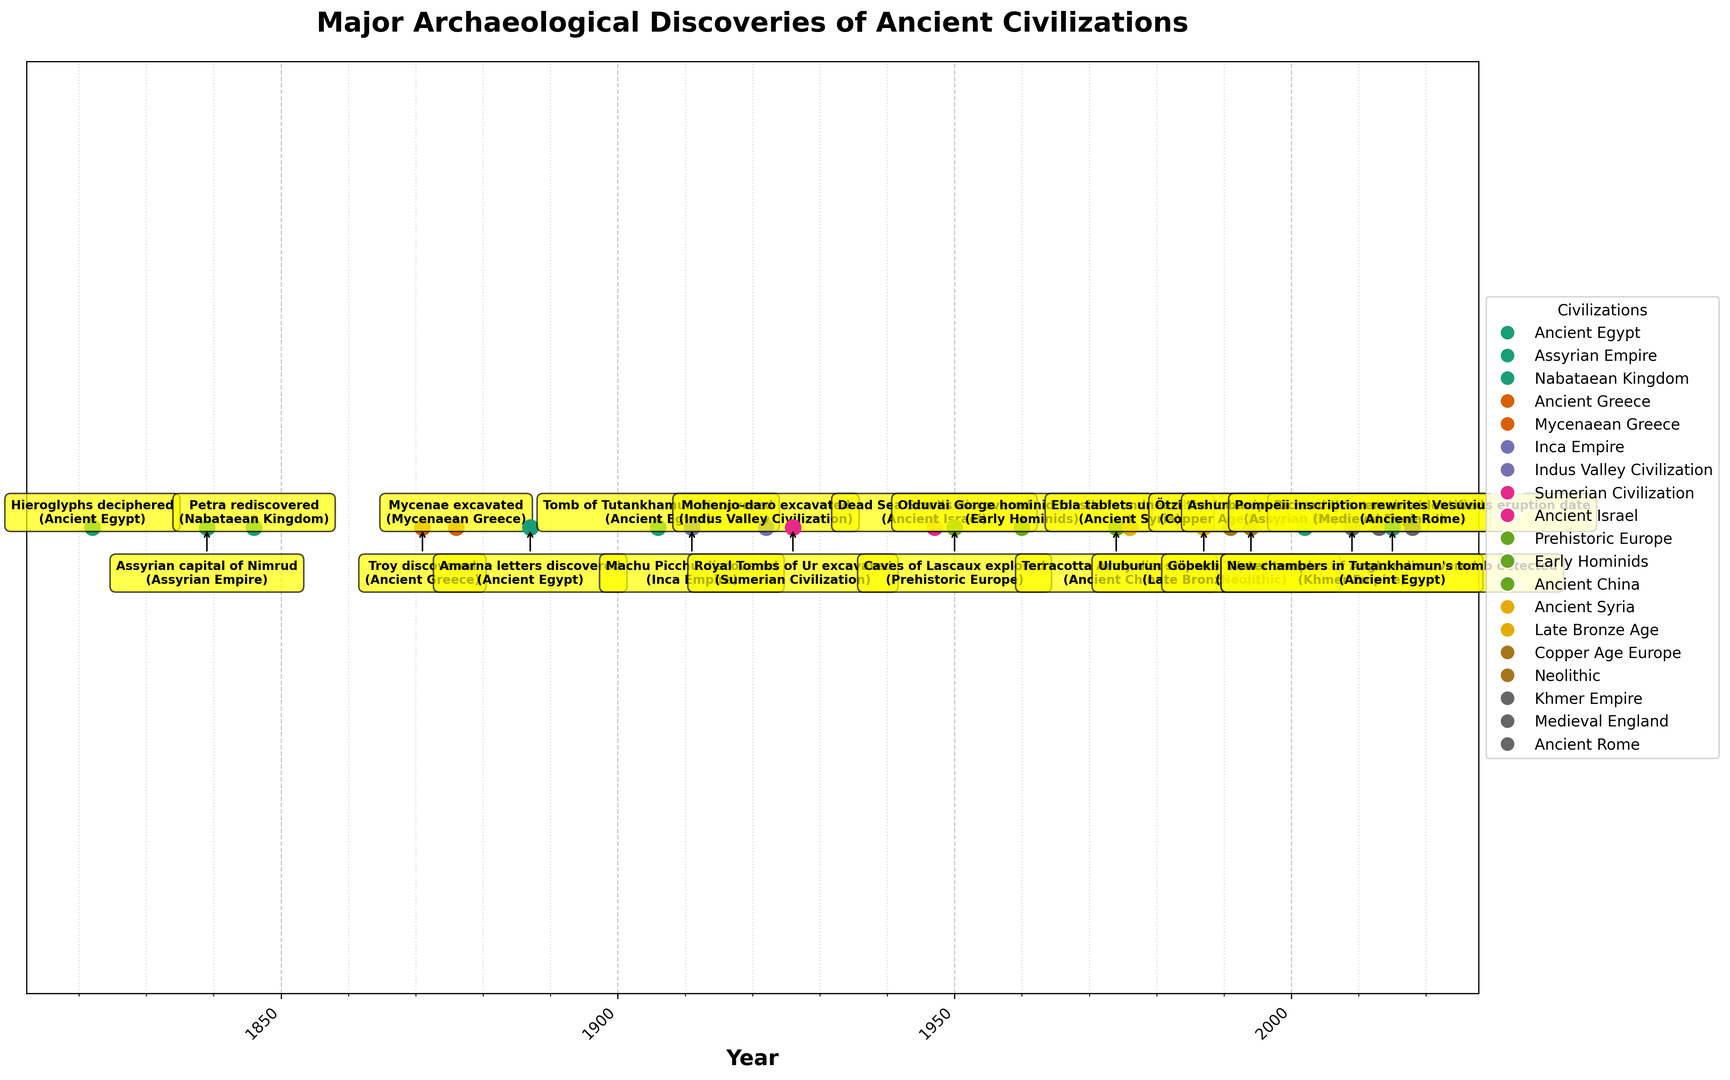What's the most recent archaeological discovery noted on the plot? The plot shows that the most recent discovery is the "Pompeii inscription rewrites Vesuvius eruption date" made in 2018. You can identify the year 2018 as the latest data point along the timeline on the x-axis.
Answer: Pompeii inscription in 2018 Which civilization had the highest number of major discoveries based on the plot? Looking at the plot, you can count the number of discoveries for each civilization. Ancient Egypt has the highest number of major discoveries with four events: Hieroglyphs deciphered (1822), Amarna letters discovered (1887), Tomb of Tutankhamun discovered (1906), and New chambers in Tutankhamun's tomb detected (2015).
Answer: Ancient Egypt What are the years of the discoveries related to the Assyrian Empire on the plot? By observing the labels and colors, we can identify the Assyrian Empire discoveries: "Assyrian capital of Nimrud" in 1839 and "Ashurbanipal's Library catalogued" in 2002.
Answer: 1839 and 2002 Which discovery related to the Neolithic era is noted on the plot, and in which year was it discovered? The plot shows the discovery of "Göbekli Tepe" associated with the Neolithic era. It was discovered in the year 1994. This can be seen by finding the label for Göbekli Tepe and noting its corresponding year.
Answer: Göbekli Tepe in 1994 Compare the discovery of Machu Picchu and the Tomb of Tutankhamun. Which came earlier and by how many years? "Machu Picchu" was discovered in 1911, and the "Tomb of Tutankhamun" was discovered in 1906. Subtracting the years gives 1911 - 1906 = 5 years. Thus, the Tomb of Tutankhamun was discovered 5 years earlier than Machu Picchu.
Answer: Tomb of Tutankhamun by 5 years Which civilizations have discoveries noted in the year 1922 and 1974 on the plot, respectively? The plot shows "Mohenjo-daro excavated" for the Indus Valley Civilization in 1922 and the "Terracotta Army discovered" for Ancient China in 1974. Identifying the labels along with their corresponding years provides this information.
Answer: Indus Valley Civilization (1922) and Ancient China (1974) List the discoveries related to Ancient Egypt in chronological order based on the plot. The discoveries related to Ancient Egypt are: Hieroglyphs deciphered (1822), Amarna letters discovered (1887), Tomb of Tutankhamun discovered (1906), and New chambers in Tutankhamun's tomb detected (2015). You can ascertain this by checking all labels associated with Ancient Egypt and their years.
Answer: Hieroglyphs deciphered (1822), Amarna letters (1887), Tomb of Tutankhamun (1906), New chambers in Tutankhamun's tomb (2015) What is the median year for the discoveries listed on the plot? To find the median year, list all the discovery years in order and find the middle value. The years are: 1822, 1839, 1846, 1871, 1876, 1887, 1906, 1911, 1922, 1926, 1947, 1950, 1960, 1974, 1976, 1987, 1991, 1994, 2002, 2009, 2013, 2015, 2018. With 23 values, the median is the 12th value: 1947.
Answer: 1947 